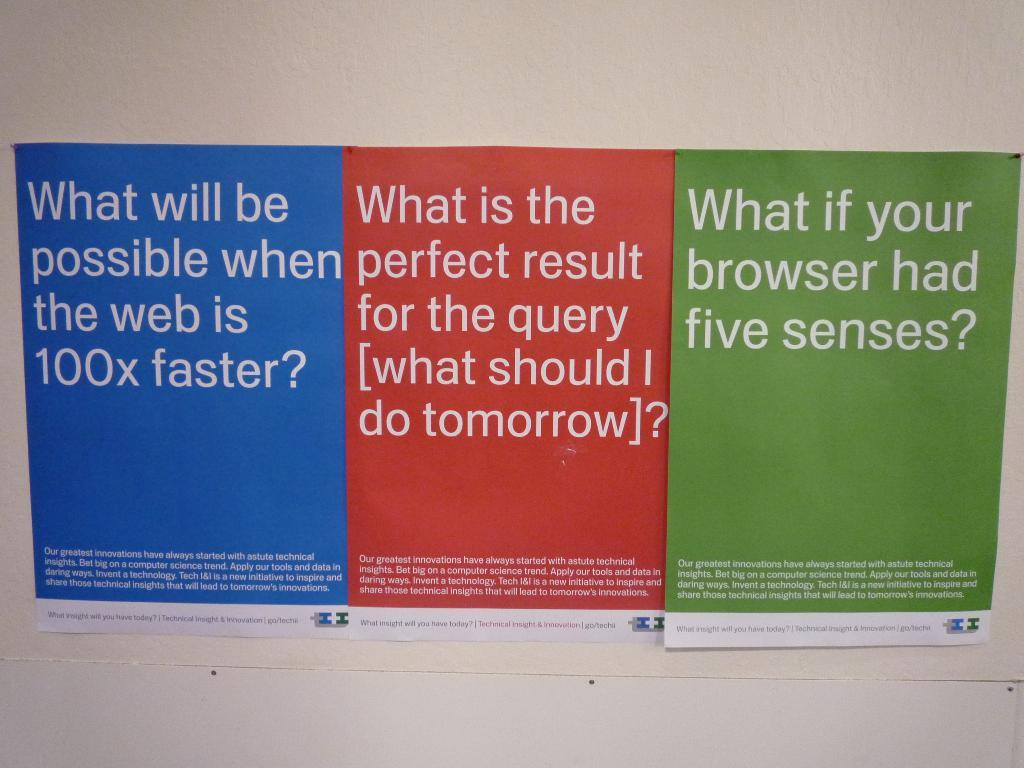Provide a one-sentence caption for the provided image. Three signs written side by side and one asking about five senses. 